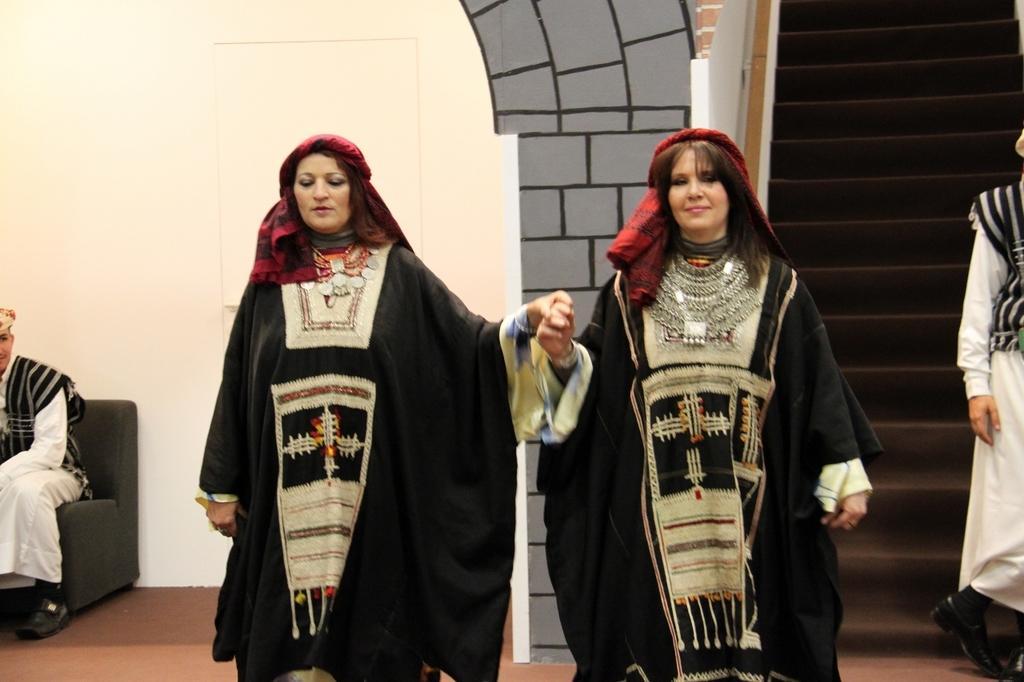Please provide a concise description of this image. In the picture I can see people among them one person is sitting on a chair and others are standing. In the background I can see a wall, steps and some other objects. 